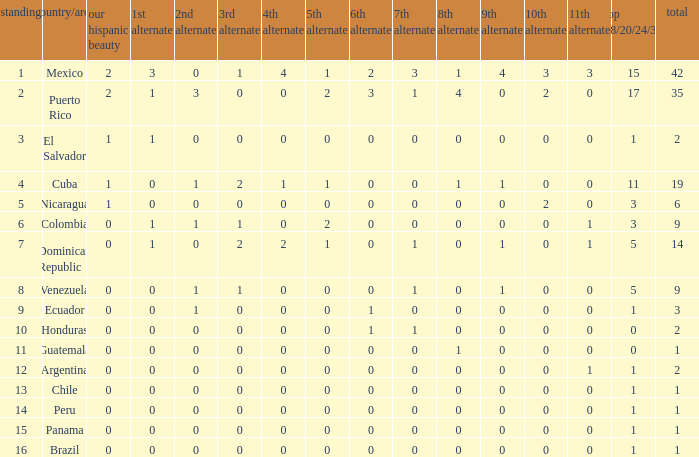What is the lowest 7th runner-up of the country with a top 18/20/24/30 greater than 5, a 1st runner-up greater than 0, and an 11th runner-up less than 0? None. 